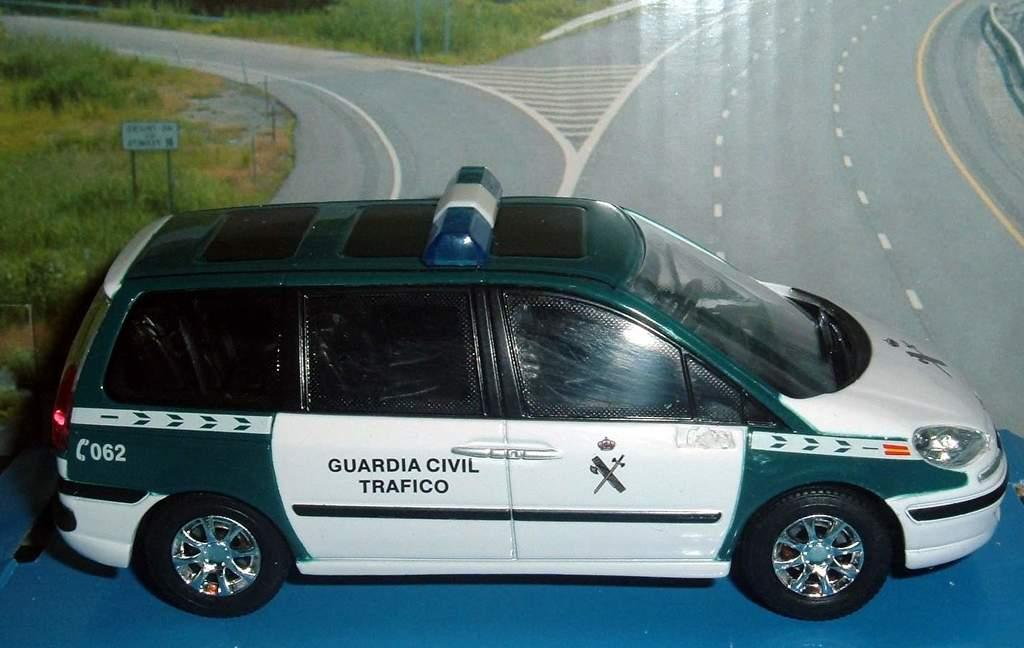Provide a one-sentence caption for the provided image. a car that has the word trafico on it. 